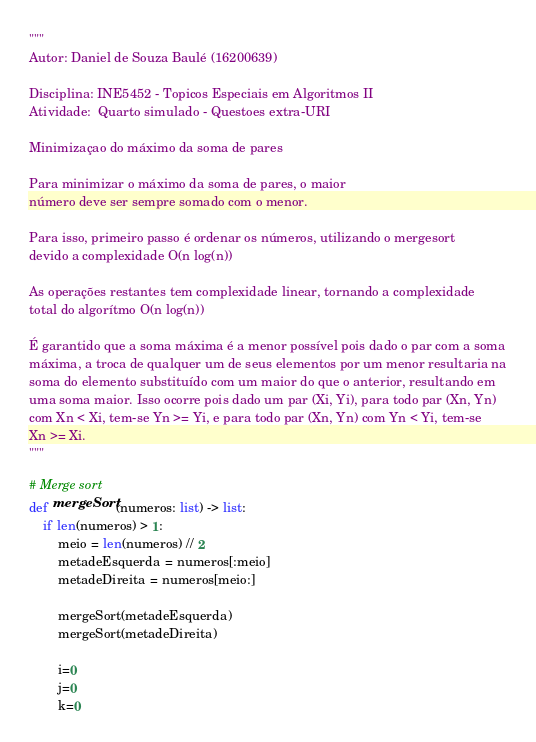<code> <loc_0><loc_0><loc_500><loc_500><_Python_>""" 
Autor: Daniel de Souza Baulé (16200639)

Disciplina: INE5452 - Topicos Especiais em Algoritmos II
Atividade:  Quarto simulado - Questoes extra-URI

Minimizaçao do máximo da soma de pares

Para minimizar o máximo da soma de pares, o maior 
número deve ser sempre somado com o menor.

Para isso, primeiro passo é ordenar os números, utilizando o mergesort
devido a complexidade O(n log(n))

As operações restantes tem complexidade linear, tornando a complexidade
total do algorítmo O(n log(n))

É garantido que a soma máxima é a menor possível pois dado o par com a soma
máxima, a troca de qualquer um de seus elementos por um menor resultaria na
soma do elemento substituído com um maior do que o anterior, resultando em
uma soma maior. Isso ocorre pois dado um par (Xi, Yi), para todo par (Xn, Yn)
com Xn < Xi, tem-se Yn >= Yi, e para todo par (Xn, Yn) com Yn < Yi, tem-se
Xn >= Xi.
"""

# Merge sort
def mergeSort(numeros: list) -> list:
    if len(numeros) > 1:
        meio = len(numeros) // 2
        metadeEsquerda = numeros[:meio]
        metadeDireita = numeros[meio:]

        mergeSort(metadeEsquerda)
        mergeSort(metadeDireita)

        i=0
        j=0
        k=0
</code> 